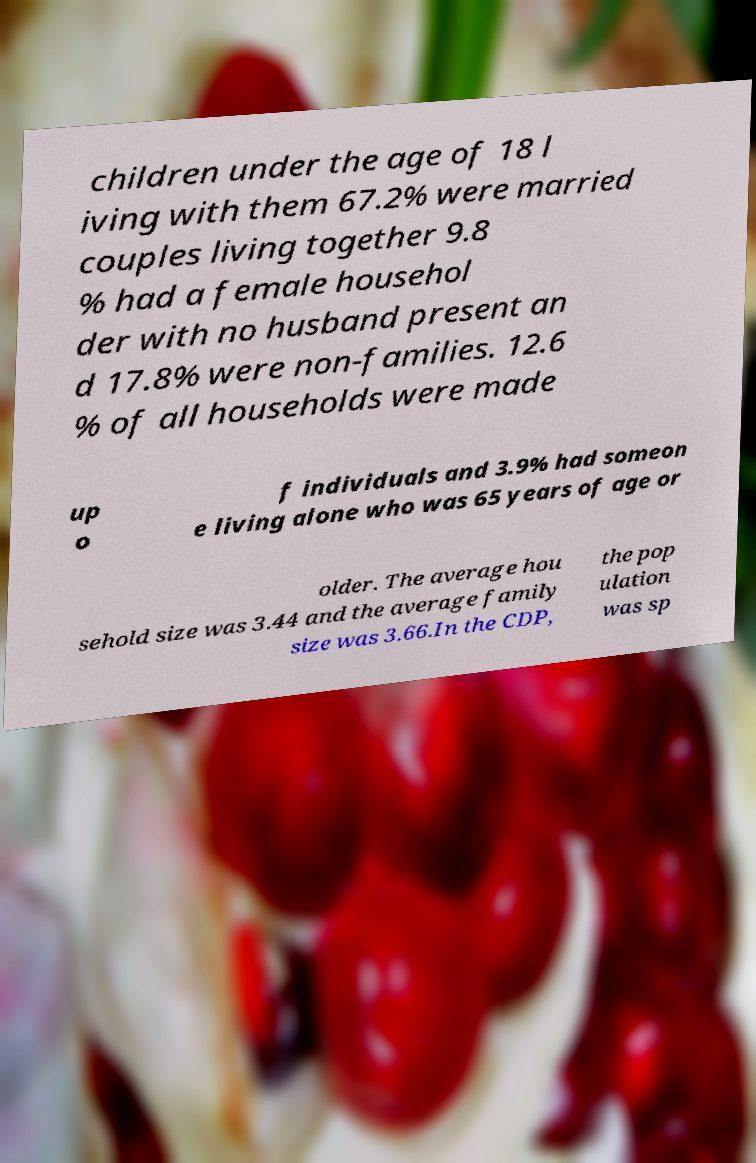What messages or text are displayed in this image? I need them in a readable, typed format. children under the age of 18 l iving with them 67.2% were married couples living together 9.8 % had a female househol der with no husband present an d 17.8% were non-families. 12.6 % of all households were made up o f individuals and 3.9% had someon e living alone who was 65 years of age or older. The average hou sehold size was 3.44 and the average family size was 3.66.In the CDP, the pop ulation was sp 